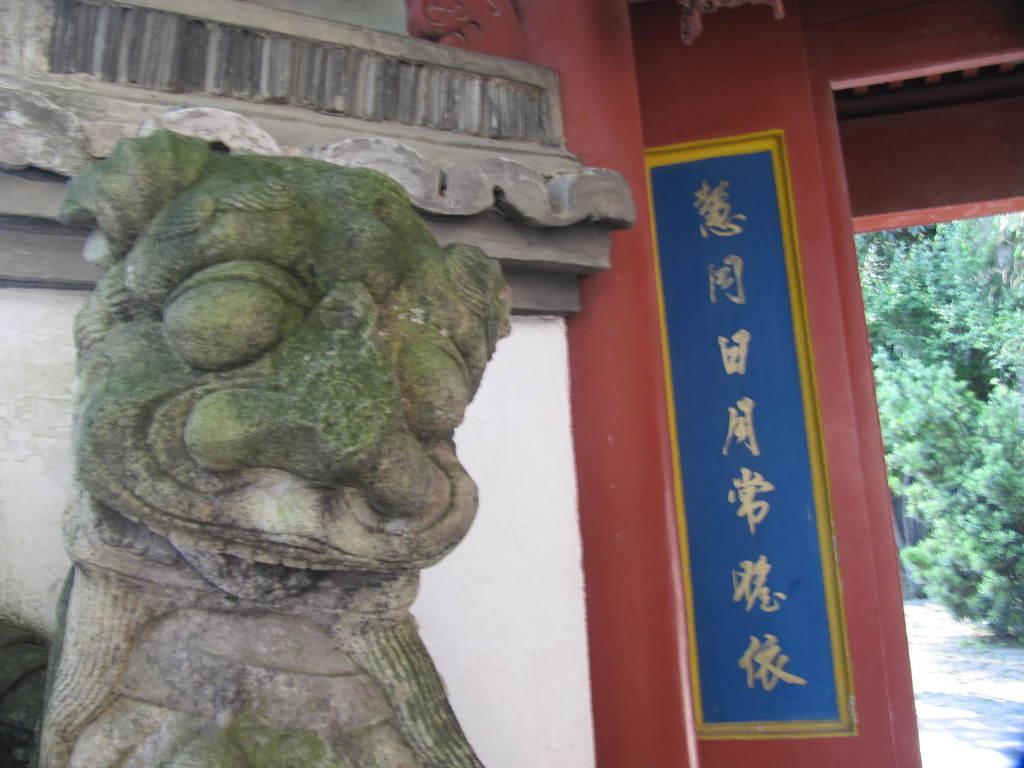Can you describe this image briefly? In the image we can see a sculpture made up of stones. This is a poster, footpath and trees. 